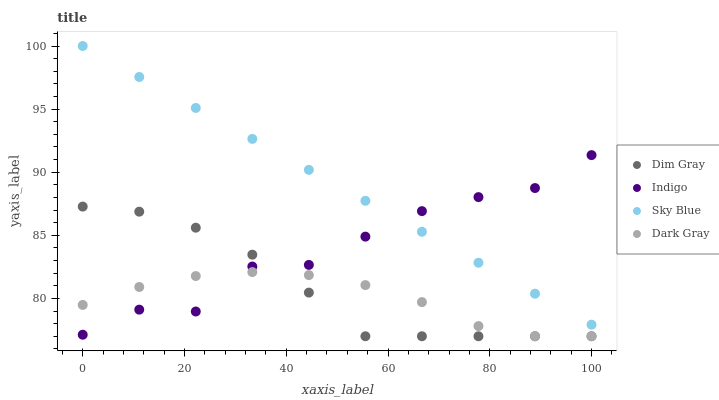Does Dark Gray have the minimum area under the curve?
Answer yes or no. Yes. Does Sky Blue have the maximum area under the curve?
Answer yes or no. Yes. Does Dim Gray have the minimum area under the curve?
Answer yes or no. No. Does Dim Gray have the maximum area under the curve?
Answer yes or no. No. Is Sky Blue the smoothest?
Answer yes or no. Yes. Is Indigo the roughest?
Answer yes or no. Yes. Is Dim Gray the smoothest?
Answer yes or no. No. Is Dim Gray the roughest?
Answer yes or no. No. Does Dark Gray have the lowest value?
Answer yes or no. Yes. Does Sky Blue have the lowest value?
Answer yes or no. No. Does Sky Blue have the highest value?
Answer yes or no. Yes. Does Dim Gray have the highest value?
Answer yes or no. No. Is Dim Gray less than Sky Blue?
Answer yes or no. Yes. Is Sky Blue greater than Dim Gray?
Answer yes or no. Yes. Does Dim Gray intersect Indigo?
Answer yes or no. Yes. Is Dim Gray less than Indigo?
Answer yes or no. No. Is Dim Gray greater than Indigo?
Answer yes or no. No. Does Dim Gray intersect Sky Blue?
Answer yes or no. No. 